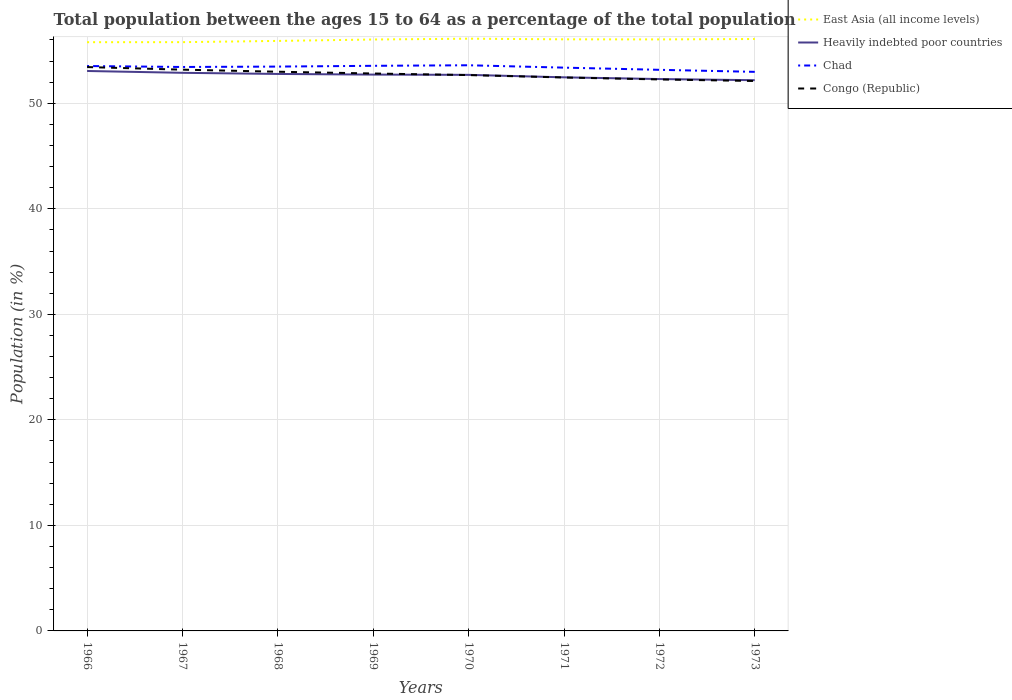Across all years, what is the maximum percentage of the population ages 15 to 64 in Chad?
Your response must be concise. 52.98. In which year was the percentage of the population ages 15 to 64 in East Asia (all income levels) maximum?
Give a very brief answer. 1966. What is the total percentage of the population ages 15 to 64 in Congo (Republic) in the graph?
Make the answer very short. 0.17. What is the difference between the highest and the second highest percentage of the population ages 15 to 64 in East Asia (all income levels)?
Offer a very short reply. 0.33. What is the difference between the highest and the lowest percentage of the population ages 15 to 64 in Chad?
Provide a succinct answer. 5. Is the percentage of the population ages 15 to 64 in Chad strictly greater than the percentage of the population ages 15 to 64 in Congo (Republic) over the years?
Your answer should be compact. No. How many lines are there?
Provide a short and direct response. 4. Does the graph contain any zero values?
Your answer should be very brief. No. Does the graph contain grids?
Provide a short and direct response. Yes. Where does the legend appear in the graph?
Your answer should be very brief. Top right. How many legend labels are there?
Offer a very short reply. 4. What is the title of the graph?
Give a very brief answer. Total population between the ages 15 to 64 as a percentage of the total population. What is the label or title of the Y-axis?
Offer a terse response. Population (in %). What is the Population (in %) of East Asia (all income levels) in 1966?
Offer a very short reply. 55.79. What is the Population (in %) of Heavily indebted poor countries in 1966?
Provide a short and direct response. 53.06. What is the Population (in %) of Chad in 1966?
Your answer should be very brief. 53.53. What is the Population (in %) in Congo (Republic) in 1966?
Make the answer very short. 53.43. What is the Population (in %) in East Asia (all income levels) in 1967?
Offer a very short reply. 55.79. What is the Population (in %) of Heavily indebted poor countries in 1967?
Offer a very short reply. 52.89. What is the Population (in %) in Chad in 1967?
Give a very brief answer. 53.44. What is the Population (in %) in Congo (Republic) in 1967?
Your response must be concise. 53.18. What is the Population (in %) in East Asia (all income levels) in 1968?
Provide a short and direct response. 55.91. What is the Population (in %) of Heavily indebted poor countries in 1968?
Make the answer very short. 52.78. What is the Population (in %) of Chad in 1968?
Offer a terse response. 53.48. What is the Population (in %) of Congo (Republic) in 1968?
Make the answer very short. 52.99. What is the Population (in %) in East Asia (all income levels) in 1969?
Offer a very short reply. 56.04. What is the Population (in %) of Heavily indebted poor countries in 1969?
Ensure brevity in your answer.  52.72. What is the Population (in %) of Chad in 1969?
Make the answer very short. 53.55. What is the Population (in %) in Congo (Republic) in 1969?
Offer a very short reply. 52.82. What is the Population (in %) of East Asia (all income levels) in 1970?
Provide a succinct answer. 56.12. What is the Population (in %) of Heavily indebted poor countries in 1970?
Your response must be concise. 52.69. What is the Population (in %) of Chad in 1970?
Keep it short and to the point. 53.6. What is the Population (in %) of Congo (Republic) in 1970?
Offer a very short reply. 52.67. What is the Population (in %) in East Asia (all income levels) in 1971?
Offer a very short reply. 56.06. What is the Population (in %) in Heavily indebted poor countries in 1971?
Your answer should be compact. 52.46. What is the Population (in %) in Chad in 1971?
Provide a succinct answer. 53.38. What is the Population (in %) of Congo (Republic) in 1971?
Your answer should be very brief. 52.44. What is the Population (in %) in East Asia (all income levels) in 1972?
Keep it short and to the point. 56.05. What is the Population (in %) of Heavily indebted poor countries in 1972?
Keep it short and to the point. 52.29. What is the Population (in %) of Chad in 1972?
Your answer should be very brief. 53.17. What is the Population (in %) of Congo (Republic) in 1972?
Give a very brief answer. 52.26. What is the Population (in %) in East Asia (all income levels) in 1973?
Your answer should be very brief. 56.09. What is the Population (in %) in Heavily indebted poor countries in 1973?
Your answer should be very brief. 52.19. What is the Population (in %) in Chad in 1973?
Provide a short and direct response. 52.98. What is the Population (in %) of Congo (Republic) in 1973?
Ensure brevity in your answer.  52.11. Across all years, what is the maximum Population (in %) of East Asia (all income levels)?
Provide a succinct answer. 56.12. Across all years, what is the maximum Population (in %) in Heavily indebted poor countries?
Your answer should be compact. 53.06. Across all years, what is the maximum Population (in %) of Chad?
Provide a short and direct response. 53.6. Across all years, what is the maximum Population (in %) of Congo (Republic)?
Provide a short and direct response. 53.43. Across all years, what is the minimum Population (in %) of East Asia (all income levels)?
Ensure brevity in your answer.  55.79. Across all years, what is the minimum Population (in %) of Heavily indebted poor countries?
Offer a very short reply. 52.19. Across all years, what is the minimum Population (in %) of Chad?
Your answer should be compact. 52.98. Across all years, what is the minimum Population (in %) in Congo (Republic)?
Offer a very short reply. 52.11. What is the total Population (in %) in East Asia (all income levels) in the graph?
Give a very brief answer. 447.84. What is the total Population (in %) in Heavily indebted poor countries in the graph?
Your answer should be very brief. 421.06. What is the total Population (in %) in Chad in the graph?
Your answer should be very brief. 427.11. What is the total Population (in %) of Congo (Republic) in the graph?
Provide a short and direct response. 421.9. What is the difference between the Population (in %) of East Asia (all income levels) in 1966 and that in 1967?
Give a very brief answer. -0. What is the difference between the Population (in %) of Heavily indebted poor countries in 1966 and that in 1967?
Ensure brevity in your answer.  0.17. What is the difference between the Population (in %) in Chad in 1966 and that in 1967?
Make the answer very short. 0.09. What is the difference between the Population (in %) of Congo (Republic) in 1966 and that in 1967?
Keep it short and to the point. 0.25. What is the difference between the Population (in %) of East Asia (all income levels) in 1966 and that in 1968?
Offer a very short reply. -0.12. What is the difference between the Population (in %) of Heavily indebted poor countries in 1966 and that in 1968?
Offer a terse response. 0.28. What is the difference between the Population (in %) of Chad in 1966 and that in 1968?
Offer a terse response. 0.05. What is the difference between the Population (in %) of Congo (Republic) in 1966 and that in 1968?
Ensure brevity in your answer.  0.44. What is the difference between the Population (in %) in East Asia (all income levels) in 1966 and that in 1969?
Your response must be concise. -0.26. What is the difference between the Population (in %) of Heavily indebted poor countries in 1966 and that in 1969?
Your answer should be compact. 0.34. What is the difference between the Population (in %) in Chad in 1966 and that in 1969?
Your response must be concise. -0.02. What is the difference between the Population (in %) of Congo (Republic) in 1966 and that in 1969?
Provide a succinct answer. 0.61. What is the difference between the Population (in %) in East Asia (all income levels) in 1966 and that in 1970?
Your answer should be compact. -0.33. What is the difference between the Population (in %) in Heavily indebted poor countries in 1966 and that in 1970?
Keep it short and to the point. 0.37. What is the difference between the Population (in %) of Chad in 1966 and that in 1970?
Your response must be concise. -0.07. What is the difference between the Population (in %) in Congo (Republic) in 1966 and that in 1970?
Ensure brevity in your answer.  0.76. What is the difference between the Population (in %) of East Asia (all income levels) in 1966 and that in 1971?
Your answer should be compact. -0.27. What is the difference between the Population (in %) of Heavily indebted poor countries in 1966 and that in 1971?
Ensure brevity in your answer.  0.6. What is the difference between the Population (in %) of Chad in 1966 and that in 1971?
Give a very brief answer. 0.15. What is the difference between the Population (in %) in Congo (Republic) in 1966 and that in 1971?
Your answer should be compact. 0.99. What is the difference between the Population (in %) of East Asia (all income levels) in 1966 and that in 1972?
Ensure brevity in your answer.  -0.26. What is the difference between the Population (in %) of Heavily indebted poor countries in 1966 and that in 1972?
Offer a terse response. 0.76. What is the difference between the Population (in %) in Chad in 1966 and that in 1972?
Offer a very short reply. 0.36. What is the difference between the Population (in %) in Congo (Republic) in 1966 and that in 1972?
Ensure brevity in your answer.  1.17. What is the difference between the Population (in %) in East Asia (all income levels) in 1966 and that in 1973?
Your answer should be compact. -0.3. What is the difference between the Population (in %) of Heavily indebted poor countries in 1966 and that in 1973?
Offer a terse response. 0.87. What is the difference between the Population (in %) of Chad in 1966 and that in 1973?
Give a very brief answer. 0.55. What is the difference between the Population (in %) in Congo (Republic) in 1966 and that in 1973?
Your answer should be very brief. 1.32. What is the difference between the Population (in %) in East Asia (all income levels) in 1967 and that in 1968?
Provide a succinct answer. -0.12. What is the difference between the Population (in %) of Heavily indebted poor countries in 1967 and that in 1968?
Ensure brevity in your answer.  0.11. What is the difference between the Population (in %) in Chad in 1967 and that in 1968?
Make the answer very short. -0.04. What is the difference between the Population (in %) of Congo (Republic) in 1967 and that in 1968?
Make the answer very short. 0.2. What is the difference between the Population (in %) of East Asia (all income levels) in 1967 and that in 1969?
Provide a succinct answer. -0.25. What is the difference between the Population (in %) of Heavily indebted poor countries in 1967 and that in 1969?
Offer a very short reply. 0.17. What is the difference between the Population (in %) in Chad in 1967 and that in 1969?
Your response must be concise. -0.11. What is the difference between the Population (in %) of Congo (Republic) in 1967 and that in 1969?
Your response must be concise. 0.36. What is the difference between the Population (in %) of East Asia (all income levels) in 1967 and that in 1970?
Make the answer very short. -0.33. What is the difference between the Population (in %) in Heavily indebted poor countries in 1967 and that in 1970?
Your response must be concise. 0.19. What is the difference between the Population (in %) of Chad in 1967 and that in 1970?
Ensure brevity in your answer.  -0.16. What is the difference between the Population (in %) in Congo (Republic) in 1967 and that in 1970?
Provide a succinct answer. 0.51. What is the difference between the Population (in %) of East Asia (all income levels) in 1967 and that in 1971?
Your answer should be very brief. -0.27. What is the difference between the Population (in %) in Heavily indebted poor countries in 1967 and that in 1971?
Make the answer very short. 0.43. What is the difference between the Population (in %) of Chad in 1967 and that in 1971?
Your response must be concise. 0.06. What is the difference between the Population (in %) of Congo (Republic) in 1967 and that in 1971?
Offer a terse response. 0.74. What is the difference between the Population (in %) in East Asia (all income levels) in 1967 and that in 1972?
Offer a very short reply. -0.26. What is the difference between the Population (in %) of Heavily indebted poor countries in 1967 and that in 1972?
Your answer should be compact. 0.59. What is the difference between the Population (in %) in Chad in 1967 and that in 1972?
Ensure brevity in your answer.  0.27. What is the difference between the Population (in %) in Congo (Republic) in 1967 and that in 1972?
Offer a very short reply. 0.93. What is the difference between the Population (in %) in East Asia (all income levels) in 1967 and that in 1973?
Your response must be concise. -0.3. What is the difference between the Population (in %) in Heavily indebted poor countries in 1967 and that in 1973?
Offer a very short reply. 0.7. What is the difference between the Population (in %) in Chad in 1967 and that in 1973?
Offer a very short reply. 0.46. What is the difference between the Population (in %) of Congo (Republic) in 1967 and that in 1973?
Offer a terse response. 1.07. What is the difference between the Population (in %) of East Asia (all income levels) in 1968 and that in 1969?
Your answer should be very brief. -0.13. What is the difference between the Population (in %) in Heavily indebted poor countries in 1968 and that in 1969?
Make the answer very short. 0.06. What is the difference between the Population (in %) in Chad in 1968 and that in 1969?
Keep it short and to the point. -0.07. What is the difference between the Population (in %) in Congo (Republic) in 1968 and that in 1969?
Your answer should be compact. 0.17. What is the difference between the Population (in %) of East Asia (all income levels) in 1968 and that in 1970?
Make the answer very short. -0.21. What is the difference between the Population (in %) of Heavily indebted poor countries in 1968 and that in 1970?
Provide a short and direct response. 0.09. What is the difference between the Population (in %) in Chad in 1968 and that in 1970?
Your answer should be very brief. -0.12. What is the difference between the Population (in %) of Congo (Republic) in 1968 and that in 1970?
Provide a succinct answer. 0.32. What is the difference between the Population (in %) of East Asia (all income levels) in 1968 and that in 1971?
Make the answer very short. -0.15. What is the difference between the Population (in %) of Heavily indebted poor countries in 1968 and that in 1971?
Your response must be concise. 0.32. What is the difference between the Population (in %) of Chad in 1968 and that in 1971?
Your answer should be very brief. 0.1. What is the difference between the Population (in %) in Congo (Republic) in 1968 and that in 1971?
Keep it short and to the point. 0.54. What is the difference between the Population (in %) in East Asia (all income levels) in 1968 and that in 1972?
Offer a very short reply. -0.14. What is the difference between the Population (in %) of Heavily indebted poor countries in 1968 and that in 1972?
Ensure brevity in your answer.  0.48. What is the difference between the Population (in %) in Chad in 1968 and that in 1972?
Offer a terse response. 0.31. What is the difference between the Population (in %) of Congo (Republic) in 1968 and that in 1972?
Ensure brevity in your answer.  0.73. What is the difference between the Population (in %) of East Asia (all income levels) in 1968 and that in 1973?
Offer a very short reply. -0.18. What is the difference between the Population (in %) of Heavily indebted poor countries in 1968 and that in 1973?
Give a very brief answer. 0.59. What is the difference between the Population (in %) of Chad in 1968 and that in 1973?
Make the answer very short. 0.5. What is the difference between the Population (in %) in Congo (Republic) in 1968 and that in 1973?
Offer a terse response. 0.88. What is the difference between the Population (in %) in East Asia (all income levels) in 1969 and that in 1970?
Keep it short and to the point. -0.08. What is the difference between the Population (in %) in Heavily indebted poor countries in 1969 and that in 1970?
Keep it short and to the point. 0.03. What is the difference between the Population (in %) in Chad in 1969 and that in 1970?
Offer a very short reply. -0.05. What is the difference between the Population (in %) in Congo (Republic) in 1969 and that in 1970?
Your answer should be compact. 0.15. What is the difference between the Population (in %) of East Asia (all income levels) in 1969 and that in 1971?
Keep it short and to the point. -0.02. What is the difference between the Population (in %) of Heavily indebted poor countries in 1969 and that in 1971?
Your answer should be very brief. 0.26. What is the difference between the Population (in %) of Chad in 1969 and that in 1971?
Your response must be concise. 0.17. What is the difference between the Population (in %) in Congo (Republic) in 1969 and that in 1971?
Ensure brevity in your answer.  0.38. What is the difference between the Population (in %) in East Asia (all income levels) in 1969 and that in 1972?
Provide a short and direct response. -0.01. What is the difference between the Population (in %) in Heavily indebted poor countries in 1969 and that in 1972?
Your answer should be very brief. 0.42. What is the difference between the Population (in %) of Chad in 1969 and that in 1972?
Provide a short and direct response. 0.38. What is the difference between the Population (in %) of Congo (Republic) in 1969 and that in 1972?
Ensure brevity in your answer.  0.56. What is the difference between the Population (in %) in East Asia (all income levels) in 1969 and that in 1973?
Your response must be concise. -0.05. What is the difference between the Population (in %) in Heavily indebted poor countries in 1969 and that in 1973?
Make the answer very short. 0.53. What is the difference between the Population (in %) in Chad in 1969 and that in 1973?
Provide a succinct answer. 0.57. What is the difference between the Population (in %) in Congo (Republic) in 1969 and that in 1973?
Your response must be concise. 0.71. What is the difference between the Population (in %) in East Asia (all income levels) in 1970 and that in 1971?
Give a very brief answer. 0.06. What is the difference between the Population (in %) in Heavily indebted poor countries in 1970 and that in 1971?
Offer a terse response. 0.23. What is the difference between the Population (in %) in Chad in 1970 and that in 1971?
Give a very brief answer. 0.22. What is the difference between the Population (in %) in Congo (Republic) in 1970 and that in 1971?
Your answer should be very brief. 0.23. What is the difference between the Population (in %) in East Asia (all income levels) in 1970 and that in 1972?
Your response must be concise. 0.07. What is the difference between the Population (in %) in Heavily indebted poor countries in 1970 and that in 1972?
Keep it short and to the point. 0.4. What is the difference between the Population (in %) of Chad in 1970 and that in 1972?
Keep it short and to the point. 0.43. What is the difference between the Population (in %) of Congo (Republic) in 1970 and that in 1972?
Offer a very short reply. 0.41. What is the difference between the Population (in %) of East Asia (all income levels) in 1970 and that in 1973?
Provide a succinct answer. 0.03. What is the difference between the Population (in %) in Heavily indebted poor countries in 1970 and that in 1973?
Your answer should be compact. 0.5. What is the difference between the Population (in %) in Chad in 1970 and that in 1973?
Offer a terse response. 0.62. What is the difference between the Population (in %) in Congo (Republic) in 1970 and that in 1973?
Make the answer very short. 0.56. What is the difference between the Population (in %) in East Asia (all income levels) in 1971 and that in 1972?
Give a very brief answer. 0.01. What is the difference between the Population (in %) of Heavily indebted poor countries in 1971 and that in 1972?
Keep it short and to the point. 0.16. What is the difference between the Population (in %) of Chad in 1971 and that in 1972?
Provide a succinct answer. 0.21. What is the difference between the Population (in %) of Congo (Republic) in 1971 and that in 1972?
Provide a succinct answer. 0.19. What is the difference between the Population (in %) in East Asia (all income levels) in 1971 and that in 1973?
Keep it short and to the point. -0.03. What is the difference between the Population (in %) in Heavily indebted poor countries in 1971 and that in 1973?
Provide a short and direct response. 0.27. What is the difference between the Population (in %) in Chad in 1971 and that in 1973?
Offer a very short reply. 0.4. What is the difference between the Population (in %) of Congo (Republic) in 1971 and that in 1973?
Your response must be concise. 0.33. What is the difference between the Population (in %) in East Asia (all income levels) in 1972 and that in 1973?
Provide a succinct answer. -0.04. What is the difference between the Population (in %) of Heavily indebted poor countries in 1972 and that in 1973?
Ensure brevity in your answer.  0.11. What is the difference between the Population (in %) of Chad in 1972 and that in 1973?
Offer a terse response. 0.19. What is the difference between the Population (in %) of Congo (Republic) in 1972 and that in 1973?
Make the answer very short. 0.15. What is the difference between the Population (in %) of East Asia (all income levels) in 1966 and the Population (in %) of Heavily indebted poor countries in 1967?
Offer a terse response. 2.9. What is the difference between the Population (in %) in East Asia (all income levels) in 1966 and the Population (in %) in Chad in 1967?
Your response must be concise. 2.35. What is the difference between the Population (in %) in East Asia (all income levels) in 1966 and the Population (in %) in Congo (Republic) in 1967?
Offer a terse response. 2.6. What is the difference between the Population (in %) in Heavily indebted poor countries in 1966 and the Population (in %) in Chad in 1967?
Provide a short and direct response. -0.38. What is the difference between the Population (in %) of Heavily indebted poor countries in 1966 and the Population (in %) of Congo (Republic) in 1967?
Offer a terse response. -0.13. What is the difference between the Population (in %) in Chad in 1966 and the Population (in %) in Congo (Republic) in 1967?
Provide a short and direct response. 0.34. What is the difference between the Population (in %) of East Asia (all income levels) in 1966 and the Population (in %) of Heavily indebted poor countries in 1968?
Give a very brief answer. 3.01. What is the difference between the Population (in %) of East Asia (all income levels) in 1966 and the Population (in %) of Chad in 1968?
Give a very brief answer. 2.31. What is the difference between the Population (in %) in East Asia (all income levels) in 1966 and the Population (in %) in Congo (Republic) in 1968?
Your answer should be compact. 2.8. What is the difference between the Population (in %) of Heavily indebted poor countries in 1966 and the Population (in %) of Chad in 1968?
Make the answer very short. -0.42. What is the difference between the Population (in %) of Heavily indebted poor countries in 1966 and the Population (in %) of Congo (Republic) in 1968?
Provide a short and direct response. 0.07. What is the difference between the Population (in %) in Chad in 1966 and the Population (in %) in Congo (Republic) in 1968?
Offer a terse response. 0.54. What is the difference between the Population (in %) of East Asia (all income levels) in 1966 and the Population (in %) of Heavily indebted poor countries in 1969?
Provide a short and direct response. 3.07. What is the difference between the Population (in %) in East Asia (all income levels) in 1966 and the Population (in %) in Chad in 1969?
Your response must be concise. 2.24. What is the difference between the Population (in %) of East Asia (all income levels) in 1966 and the Population (in %) of Congo (Republic) in 1969?
Your answer should be very brief. 2.97. What is the difference between the Population (in %) in Heavily indebted poor countries in 1966 and the Population (in %) in Chad in 1969?
Your answer should be very brief. -0.49. What is the difference between the Population (in %) of Heavily indebted poor countries in 1966 and the Population (in %) of Congo (Republic) in 1969?
Make the answer very short. 0.24. What is the difference between the Population (in %) of Chad in 1966 and the Population (in %) of Congo (Republic) in 1969?
Provide a short and direct response. 0.71. What is the difference between the Population (in %) in East Asia (all income levels) in 1966 and the Population (in %) in Heavily indebted poor countries in 1970?
Your response must be concise. 3.1. What is the difference between the Population (in %) in East Asia (all income levels) in 1966 and the Population (in %) in Chad in 1970?
Make the answer very short. 2.19. What is the difference between the Population (in %) in East Asia (all income levels) in 1966 and the Population (in %) in Congo (Republic) in 1970?
Provide a succinct answer. 3.12. What is the difference between the Population (in %) of Heavily indebted poor countries in 1966 and the Population (in %) of Chad in 1970?
Your answer should be very brief. -0.54. What is the difference between the Population (in %) in Heavily indebted poor countries in 1966 and the Population (in %) in Congo (Republic) in 1970?
Give a very brief answer. 0.39. What is the difference between the Population (in %) of Chad in 1966 and the Population (in %) of Congo (Republic) in 1970?
Provide a short and direct response. 0.86. What is the difference between the Population (in %) of East Asia (all income levels) in 1966 and the Population (in %) of Heavily indebted poor countries in 1971?
Your answer should be compact. 3.33. What is the difference between the Population (in %) in East Asia (all income levels) in 1966 and the Population (in %) in Chad in 1971?
Make the answer very short. 2.41. What is the difference between the Population (in %) of East Asia (all income levels) in 1966 and the Population (in %) of Congo (Republic) in 1971?
Give a very brief answer. 3.34. What is the difference between the Population (in %) of Heavily indebted poor countries in 1966 and the Population (in %) of Chad in 1971?
Ensure brevity in your answer.  -0.32. What is the difference between the Population (in %) of Heavily indebted poor countries in 1966 and the Population (in %) of Congo (Republic) in 1971?
Offer a very short reply. 0.61. What is the difference between the Population (in %) of Chad in 1966 and the Population (in %) of Congo (Republic) in 1971?
Give a very brief answer. 1.09. What is the difference between the Population (in %) of East Asia (all income levels) in 1966 and the Population (in %) of Heavily indebted poor countries in 1972?
Provide a succinct answer. 3.49. What is the difference between the Population (in %) in East Asia (all income levels) in 1966 and the Population (in %) in Chad in 1972?
Make the answer very short. 2.62. What is the difference between the Population (in %) in East Asia (all income levels) in 1966 and the Population (in %) in Congo (Republic) in 1972?
Keep it short and to the point. 3.53. What is the difference between the Population (in %) in Heavily indebted poor countries in 1966 and the Population (in %) in Chad in 1972?
Your answer should be compact. -0.11. What is the difference between the Population (in %) of Heavily indebted poor countries in 1966 and the Population (in %) of Congo (Republic) in 1972?
Your answer should be very brief. 0.8. What is the difference between the Population (in %) of Chad in 1966 and the Population (in %) of Congo (Republic) in 1972?
Your answer should be very brief. 1.27. What is the difference between the Population (in %) in East Asia (all income levels) in 1966 and the Population (in %) in Heavily indebted poor countries in 1973?
Your response must be concise. 3.6. What is the difference between the Population (in %) in East Asia (all income levels) in 1966 and the Population (in %) in Chad in 1973?
Keep it short and to the point. 2.81. What is the difference between the Population (in %) of East Asia (all income levels) in 1966 and the Population (in %) of Congo (Republic) in 1973?
Make the answer very short. 3.68. What is the difference between the Population (in %) in Heavily indebted poor countries in 1966 and the Population (in %) in Chad in 1973?
Give a very brief answer. 0.08. What is the difference between the Population (in %) of Heavily indebted poor countries in 1966 and the Population (in %) of Congo (Republic) in 1973?
Ensure brevity in your answer.  0.95. What is the difference between the Population (in %) of Chad in 1966 and the Population (in %) of Congo (Republic) in 1973?
Offer a terse response. 1.42. What is the difference between the Population (in %) in East Asia (all income levels) in 1967 and the Population (in %) in Heavily indebted poor countries in 1968?
Your answer should be compact. 3.01. What is the difference between the Population (in %) of East Asia (all income levels) in 1967 and the Population (in %) of Chad in 1968?
Make the answer very short. 2.31. What is the difference between the Population (in %) of East Asia (all income levels) in 1967 and the Population (in %) of Congo (Republic) in 1968?
Offer a very short reply. 2.8. What is the difference between the Population (in %) of Heavily indebted poor countries in 1967 and the Population (in %) of Chad in 1968?
Provide a short and direct response. -0.59. What is the difference between the Population (in %) in Heavily indebted poor countries in 1967 and the Population (in %) in Congo (Republic) in 1968?
Give a very brief answer. -0.1. What is the difference between the Population (in %) of Chad in 1967 and the Population (in %) of Congo (Republic) in 1968?
Give a very brief answer. 0.45. What is the difference between the Population (in %) of East Asia (all income levels) in 1967 and the Population (in %) of Heavily indebted poor countries in 1969?
Provide a short and direct response. 3.07. What is the difference between the Population (in %) in East Asia (all income levels) in 1967 and the Population (in %) in Chad in 1969?
Make the answer very short. 2.24. What is the difference between the Population (in %) in East Asia (all income levels) in 1967 and the Population (in %) in Congo (Republic) in 1969?
Provide a short and direct response. 2.97. What is the difference between the Population (in %) in Heavily indebted poor countries in 1967 and the Population (in %) in Chad in 1969?
Keep it short and to the point. -0.66. What is the difference between the Population (in %) in Heavily indebted poor countries in 1967 and the Population (in %) in Congo (Republic) in 1969?
Keep it short and to the point. 0.07. What is the difference between the Population (in %) in Chad in 1967 and the Population (in %) in Congo (Republic) in 1969?
Ensure brevity in your answer.  0.62. What is the difference between the Population (in %) of East Asia (all income levels) in 1967 and the Population (in %) of Heavily indebted poor countries in 1970?
Keep it short and to the point. 3.1. What is the difference between the Population (in %) of East Asia (all income levels) in 1967 and the Population (in %) of Chad in 1970?
Keep it short and to the point. 2.19. What is the difference between the Population (in %) of East Asia (all income levels) in 1967 and the Population (in %) of Congo (Republic) in 1970?
Your response must be concise. 3.12. What is the difference between the Population (in %) in Heavily indebted poor countries in 1967 and the Population (in %) in Chad in 1970?
Your response must be concise. -0.71. What is the difference between the Population (in %) in Heavily indebted poor countries in 1967 and the Population (in %) in Congo (Republic) in 1970?
Provide a succinct answer. 0.21. What is the difference between the Population (in %) of Chad in 1967 and the Population (in %) of Congo (Republic) in 1970?
Your response must be concise. 0.77. What is the difference between the Population (in %) in East Asia (all income levels) in 1967 and the Population (in %) in Heavily indebted poor countries in 1971?
Make the answer very short. 3.33. What is the difference between the Population (in %) of East Asia (all income levels) in 1967 and the Population (in %) of Chad in 1971?
Make the answer very short. 2.41. What is the difference between the Population (in %) of East Asia (all income levels) in 1967 and the Population (in %) of Congo (Republic) in 1971?
Your answer should be compact. 3.35. What is the difference between the Population (in %) of Heavily indebted poor countries in 1967 and the Population (in %) of Chad in 1971?
Give a very brief answer. -0.49. What is the difference between the Population (in %) of Heavily indebted poor countries in 1967 and the Population (in %) of Congo (Republic) in 1971?
Give a very brief answer. 0.44. What is the difference between the Population (in %) of Chad in 1967 and the Population (in %) of Congo (Republic) in 1971?
Your answer should be compact. 0.99. What is the difference between the Population (in %) of East Asia (all income levels) in 1967 and the Population (in %) of Heavily indebted poor countries in 1972?
Offer a very short reply. 3.5. What is the difference between the Population (in %) of East Asia (all income levels) in 1967 and the Population (in %) of Chad in 1972?
Make the answer very short. 2.62. What is the difference between the Population (in %) in East Asia (all income levels) in 1967 and the Population (in %) in Congo (Republic) in 1972?
Make the answer very short. 3.53. What is the difference between the Population (in %) of Heavily indebted poor countries in 1967 and the Population (in %) of Chad in 1972?
Provide a succinct answer. -0.28. What is the difference between the Population (in %) of Heavily indebted poor countries in 1967 and the Population (in %) of Congo (Republic) in 1972?
Your response must be concise. 0.63. What is the difference between the Population (in %) of Chad in 1967 and the Population (in %) of Congo (Republic) in 1972?
Provide a succinct answer. 1.18. What is the difference between the Population (in %) of East Asia (all income levels) in 1967 and the Population (in %) of Heavily indebted poor countries in 1973?
Keep it short and to the point. 3.6. What is the difference between the Population (in %) of East Asia (all income levels) in 1967 and the Population (in %) of Chad in 1973?
Offer a terse response. 2.81. What is the difference between the Population (in %) in East Asia (all income levels) in 1967 and the Population (in %) in Congo (Republic) in 1973?
Provide a succinct answer. 3.68. What is the difference between the Population (in %) in Heavily indebted poor countries in 1967 and the Population (in %) in Chad in 1973?
Provide a short and direct response. -0.09. What is the difference between the Population (in %) of Heavily indebted poor countries in 1967 and the Population (in %) of Congo (Republic) in 1973?
Make the answer very short. 0.78. What is the difference between the Population (in %) in Chad in 1967 and the Population (in %) in Congo (Republic) in 1973?
Give a very brief answer. 1.33. What is the difference between the Population (in %) in East Asia (all income levels) in 1968 and the Population (in %) in Heavily indebted poor countries in 1969?
Provide a succinct answer. 3.19. What is the difference between the Population (in %) in East Asia (all income levels) in 1968 and the Population (in %) in Chad in 1969?
Your answer should be compact. 2.36. What is the difference between the Population (in %) in East Asia (all income levels) in 1968 and the Population (in %) in Congo (Republic) in 1969?
Your answer should be compact. 3.09. What is the difference between the Population (in %) in Heavily indebted poor countries in 1968 and the Population (in %) in Chad in 1969?
Ensure brevity in your answer.  -0.77. What is the difference between the Population (in %) of Heavily indebted poor countries in 1968 and the Population (in %) of Congo (Republic) in 1969?
Your response must be concise. -0.04. What is the difference between the Population (in %) in Chad in 1968 and the Population (in %) in Congo (Republic) in 1969?
Offer a very short reply. 0.66. What is the difference between the Population (in %) in East Asia (all income levels) in 1968 and the Population (in %) in Heavily indebted poor countries in 1970?
Ensure brevity in your answer.  3.22. What is the difference between the Population (in %) in East Asia (all income levels) in 1968 and the Population (in %) in Chad in 1970?
Offer a very short reply. 2.31. What is the difference between the Population (in %) in East Asia (all income levels) in 1968 and the Population (in %) in Congo (Republic) in 1970?
Your answer should be compact. 3.24. What is the difference between the Population (in %) in Heavily indebted poor countries in 1968 and the Population (in %) in Chad in 1970?
Your answer should be very brief. -0.82. What is the difference between the Population (in %) in Heavily indebted poor countries in 1968 and the Population (in %) in Congo (Republic) in 1970?
Make the answer very short. 0.11. What is the difference between the Population (in %) in Chad in 1968 and the Population (in %) in Congo (Republic) in 1970?
Ensure brevity in your answer.  0.8. What is the difference between the Population (in %) of East Asia (all income levels) in 1968 and the Population (in %) of Heavily indebted poor countries in 1971?
Offer a very short reply. 3.45. What is the difference between the Population (in %) in East Asia (all income levels) in 1968 and the Population (in %) in Chad in 1971?
Provide a succinct answer. 2.53. What is the difference between the Population (in %) in East Asia (all income levels) in 1968 and the Population (in %) in Congo (Republic) in 1971?
Make the answer very short. 3.46. What is the difference between the Population (in %) in Heavily indebted poor countries in 1968 and the Population (in %) in Chad in 1971?
Provide a succinct answer. -0.6. What is the difference between the Population (in %) in Heavily indebted poor countries in 1968 and the Population (in %) in Congo (Republic) in 1971?
Keep it short and to the point. 0.33. What is the difference between the Population (in %) of Chad in 1968 and the Population (in %) of Congo (Republic) in 1971?
Give a very brief answer. 1.03. What is the difference between the Population (in %) of East Asia (all income levels) in 1968 and the Population (in %) of Heavily indebted poor countries in 1972?
Your answer should be very brief. 3.61. What is the difference between the Population (in %) in East Asia (all income levels) in 1968 and the Population (in %) in Chad in 1972?
Provide a succinct answer. 2.74. What is the difference between the Population (in %) in East Asia (all income levels) in 1968 and the Population (in %) in Congo (Republic) in 1972?
Ensure brevity in your answer.  3.65. What is the difference between the Population (in %) in Heavily indebted poor countries in 1968 and the Population (in %) in Chad in 1972?
Offer a very short reply. -0.39. What is the difference between the Population (in %) in Heavily indebted poor countries in 1968 and the Population (in %) in Congo (Republic) in 1972?
Give a very brief answer. 0.52. What is the difference between the Population (in %) in Chad in 1968 and the Population (in %) in Congo (Republic) in 1972?
Offer a terse response. 1.22. What is the difference between the Population (in %) of East Asia (all income levels) in 1968 and the Population (in %) of Heavily indebted poor countries in 1973?
Give a very brief answer. 3.72. What is the difference between the Population (in %) in East Asia (all income levels) in 1968 and the Population (in %) in Chad in 1973?
Your answer should be compact. 2.93. What is the difference between the Population (in %) of East Asia (all income levels) in 1968 and the Population (in %) of Congo (Republic) in 1973?
Your answer should be very brief. 3.8. What is the difference between the Population (in %) of Heavily indebted poor countries in 1968 and the Population (in %) of Chad in 1973?
Keep it short and to the point. -0.2. What is the difference between the Population (in %) of Heavily indebted poor countries in 1968 and the Population (in %) of Congo (Republic) in 1973?
Offer a terse response. 0.67. What is the difference between the Population (in %) of Chad in 1968 and the Population (in %) of Congo (Republic) in 1973?
Ensure brevity in your answer.  1.37. What is the difference between the Population (in %) of East Asia (all income levels) in 1969 and the Population (in %) of Heavily indebted poor countries in 1970?
Provide a short and direct response. 3.35. What is the difference between the Population (in %) of East Asia (all income levels) in 1969 and the Population (in %) of Chad in 1970?
Ensure brevity in your answer.  2.44. What is the difference between the Population (in %) in East Asia (all income levels) in 1969 and the Population (in %) in Congo (Republic) in 1970?
Provide a short and direct response. 3.37. What is the difference between the Population (in %) of Heavily indebted poor countries in 1969 and the Population (in %) of Chad in 1970?
Keep it short and to the point. -0.88. What is the difference between the Population (in %) in Heavily indebted poor countries in 1969 and the Population (in %) in Congo (Republic) in 1970?
Keep it short and to the point. 0.05. What is the difference between the Population (in %) of Chad in 1969 and the Population (in %) of Congo (Republic) in 1970?
Offer a very short reply. 0.88. What is the difference between the Population (in %) of East Asia (all income levels) in 1969 and the Population (in %) of Heavily indebted poor countries in 1971?
Offer a terse response. 3.58. What is the difference between the Population (in %) of East Asia (all income levels) in 1969 and the Population (in %) of Chad in 1971?
Your answer should be very brief. 2.67. What is the difference between the Population (in %) of East Asia (all income levels) in 1969 and the Population (in %) of Congo (Republic) in 1971?
Offer a very short reply. 3.6. What is the difference between the Population (in %) of Heavily indebted poor countries in 1969 and the Population (in %) of Chad in 1971?
Make the answer very short. -0.66. What is the difference between the Population (in %) of Heavily indebted poor countries in 1969 and the Population (in %) of Congo (Republic) in 1971?
Provide a short and direct response. 0.27. What is the difference between the Population (in %) in Chad in 1969 and the Population (in %) in Congo (Republic) in 1971?
Give a very brief answer. 1.11. What is the difference between the Population (in %) in East Asia (all income levels) in 1969 and the Population (in %) in Heavily indebted poor countries in 1972?
Provide a succinct answer. 3.75. What is the difference between the Population (in %) in East Asia (all income levels) in 1969 and the Population (in %) in Chad in 1972?
Keep it short and to the point. 2.87. What is the difference between the Population (in %) of East Asia (all income levels) in 1969 and the Population (in %) of Congo (Republic) in 1972?
Your answer should be compact. 3.78. What is the difference between the Population (in %) of Heavily indebted poor countries in 1969 and the Population (in %) of Chad in 1972?
Make the answer very short. -0.45. What is the difference between the Population (in %) in Heavily indebted poor countries in 1969 and the Population (in %) in Congo (Republic) in 1972?
Provide a short and direct response. 0.46. What is the difference between the Population (in %) of Chad in 1969 and the Population (in %) of Congo (Republic) in 1972?
Your answer should be compact. 1.29. What is the difference between the Population (in %) of East Asia (all income levels) in 1969 and the Population (in %) of Heavily indebted poor countries in 1973?
Give a very brief answer. 3.85. What is the difference between the Population (in %) of East Asia (all income levels) in 1969 and the Population (in %) of Chad in 1973?
Give a very brief answer. 3.07. What is the difference between the Population (in %) in East Asia (all income levels) in 1969 and the Population (in %) in Congo (Republic) in 1973?
Make the answer very short. 3.93. What is the difference between the Population (in %) of Heavily indebted poor countries in 1969 and the Population (in %) of Chad in 1973?
Your answer should be very brief. -0.26. What is the difference between the Population (in %) of Heavily indebted poor countries in 1969 and the Population (in %) of Congo (Republic) in 1973?
Offer a very short reply. 0.61. What is the difference between the Population (in %) in Chad in 1969 and the Population (in %) in Congo (Republic) in 1973?
Offer a terse response. 1.44. What is the difference between the Population (in %) of East Asia (all income levels) in 1970 and the Population (in %) of Heavily indebted poor countries in 1971?
Keep it short and to the point. 3.66. What is the difference between the Population (in %) of East Asia (all income levels) in 1970 and the Population (in %) of Chad in 1971?
Provide a succinct answer. 2.74. What is the difference between the Population (in %) of East Asia (all income levels) in 1970 and the Population (in %) of Congo (Republic) in 1971?
Ensure brevity in your answer.  3.68. What is the difference between the Population (in %) in Heavily indebted poor countries in 1970 and the Population (in %) in Chad in 1971?
Ensure brevity in your answer.  -0.68. What is the difference between the Population (in %) in Heavily indebted poor countries in 1970 and the Population (in %) in Congo (Republic) in 1971?
Keep it short and to the point. 0.25. What is the difference between the Population (in %) of Chad in 1970 and the Population (in %) of Congo (Republic) in 1971?
Offer a terse response. 1.16. What is the difference between the Population (in %) in East Asia (all income levels) in 1970 and the Population (in %) in Heavily indebted poor countries in 1972?
Your answer should be very brief. 3.82. What is the difference between the Population (in %) in East Asia (all income levels) in 1970 and the Population (in %) in Chad in 1972?
Ensure brevity in your answer.  2.95. What is the difference between the Population (in %) of East Asia (all income levels) in 1970 and the Population (in %) of Congo (Republic) in 1972?
Offer a very short reply. 3.86. What is the difference between the Population (in %) in Heavily indebted poor countries in 1970 and the Population (in %) in Chad in 1972?
Your answer should be very brief. -0.48. What is the difference between the Population (in %) of Heavily indebted poor countries in 1970 and the Population (in %) of Congo (Republic) in 1972?
Your answer should be very brief. 0.43. What is the difference between the Population (in %) of Chad in 1970 and the Population (in %) of Congo (Republic) in 1972?
Provide a succinct answer. 1.34. What is the difference between the Population (in %) of East Asia (all income levels) in 1970 and the Population (in %) of Heavily indebted poor countries in 1973?
Your answer should be very brief. 3.93. What is the difference between the Population (in %) in East Asia (all income levels) in 1970 and the Population (in %) in Chad in 1973?
Provide a short and direct response. 3.14. What is the difference between the Population (in %) in East Asia (all income levels) in 1970 and the Population (in %) in Congo (Republic) in 1973?
Your answer should be compact. 4.01. What is the difference between the Population (in %) of Heavily indebted poor countries in 1970 and the Population (in %) of Chad in 1973?
Ensure brevity in your answer.  -0.29. What is the difference between the Population (in %) of Heavily indebted poor countries in 1970 and the Population (in %) of Congo (Republic) in 1973?
Offer a very short reply. 0.58. What is the difference between the Population (in %) in Chad in 1970 and the Population (in %) in Congo (Republic) in 1973?
Provide a short and direct response. 1.49. What is the difference between the Population (in %) in East Asia (all income levels) in 1971 and the Population (in %) in Heavily indebted poor countries in 1972?
Offer a very short reply. 3.77. What is the difference between the Population (in %) of East Asia (all income levels) in 1971 and the Population (in %) of Chad in 1972?
Offer a terse response. 2.89. What is the difference between the Population (in %) of East Asia (all income levels) in 1971 and the Population (in %) of Congo (Republic) in 1972?
Offer a terse response. 3.8. What is the difference between the Population (in %) of Heavily indebted poor countries in 1971 and the Population (in %) of Chad in 1972?
Offer a very short reply. -0.71. What is the difference between the Population (in %) of Heavily indebted poor countries in 1971 and the Population (in %) of Congo (Republic) in 1972?
Your answer should be compact. 0.2. What is the difference between the Population (in %) of Chad in 1971 and the Population (in %) of Congo (Republic) in 1972?
Make the answer very short. 1.12. What is the difference between the Population (in %) in East Asia (all income levels) in 1971 and the Population (in %) in Heavily indebted poor countries in 1973?
Make the answer very short. 3.87. What is the difference between the Population (in %) in East Asia (all income levels) in 1971 and the Population (in %) in Chad in 1973?
Provide a short and direct response. 3.08. What is the difference between the Population (in %) in East Asia (all income levels) in 1971 and the Population (in %) in Congo (Republic) in 1973?
Offer a terse response. 3.95. What is the difference between the Population (in %) in Heavily indebted poor countries in 1971 and the Population (in %) in Chad in 1973?
Offer a very short reply. -0.52. What is the difference between the Population (in %) in Heavily indebted poor countries in 1971 and the Population (in %) in Congo (Republic) in 1973?
Your answer should be very brief. 0.35. What is the difference between the Population (in %) of Chad in 1971 and the Population (in %) of Congo (Republic) in 1973?
Your response must be concise. 1.27. What is the difference between the Population (in %) of East Asia (all income levels) in 1972 and the Population (in %) of Heavily indebted poor countries in 1973?
Ensure brevity in your answer.  3.86. What is the difference between the Population (in %) of East Asia (all income levels) in 1972 and the Population (in %) of Chad in 1973?
Your response must be concise. 3.07. What is the difference between the Population (in %) in East Asia (all income levels) in 1972 and the Population (in %) in Congo (Republic) in 1973?
Offer a very short reply. 3.94. What is the difference between the Population (in %) in Heavily indebted poor countries in 1972 and the Population (in %) in Chad in 1973?
Make the answer very short. -0.68. What is the difference between the Population (in %) of Heavily indebted poor countries in 1972 and the Population (in %) of Congo (Republic) in 1973?
Your answer should be very brief. 0.18. What is the difference between the Population (in %) in Chad in 1972 and the Population (in %) in Congo (Republic) in 1973?
Your answer should be compact. 1.06. What is the average Population (in %) of East Asia (all income levels) per year?
Your response must be concise. 55.98. What is the average Population (in %) of Heavily indebted poor countries per year?
Provide a short and direct response. 52.63. What is the average Population (in %) in Chad per year?
Give a very brief answer. 53.39. What is the average Population (in %) in Congo (Republic) per year?
Keep it short and to the point. 52.74. In the year 1966, what is the difference between the Population (in %) of East Asia (all income levels) and Population (in %) of Heavily indebted poor countries?
Provide a short and direct response. 2.73. In the year 1966, what is the difference between the Population (in %) in East Asia (all income levels) and Population (in %) in Chad?
Ensure brevity in your answer.  2.26. In the year 1966, what is the difference between the Population (in %) in East Asia (all income levels) and Population (in %) in Congo (Republic)?
Your answer should be very brief. 2.36. In the year 1966, what is the difference between the Population (in %) of Heavily indebted poor countries and Population (in %) of Chad?
Offer a very short reply. -0.47. In the year 1966, what is the difference between the Population (in %) of Heavily indebted poor countries and Population (in %) of Congo (Republic)?
Provide a succinct answer. -0.37. In the year 1966, what is the difference between the Population (in %) in Chad and Population (in %) in Congo (Republic)?
Keep it short and to the point. 0.1. In the year 1967, what is the difference between the Population (in %) of East Asia (all income levels) and Population (in %) of Heavily indebted poor countries?
Provide a short and direct response. 2.9. In the year 1967, what is the difference between the Population (in %) of East Asia (all income levels) and Population (in %) of Chad?
Offer a terse response. 2.35. In the year 1967, what is the difference between the Population (in %) in East Asia (all income levels) and Population (in %) in Congo (Republic)?
Ensure brevity in your answer.  2.61. In the year 1967, what is the difference between the Population (in %) of Heavily indebted poor countries and Population (in %) of Chad?
Give a very brief answer. -0.55. In the year 1967, what is the difference between the Population (in %) of Heavily indebted poor countries and Population (in %) of Congo (Republic)?
Keep it short and to the point. -0.3. In the year 1967, what is the difference between the Population (in %) in Chad and Population (in %) in Congo (Republic)?
Give a very brief answer. 0.25. In the year 1968, what is the difference between the Population (in %) in East Asia (all income levels) and Population (in %) in Heavily indebted poor countries?
Provide a short and direct response. 3.13. In the year 1968, what is the difference between the Population (in %) of East Asia (all income levels) and Population (in %) of Chad?
Provide a short and direct response. 2.43. In the year 1968, what is the difference between the Population (in %) in East Asia (all income levels) and Population (in %) in Congo (Republic)?
Your answer should be compact. 2.92. In the year 1968, what is the difference between the Population (in %) in Heavily indebted poor countries and Population (in %) in Chad?
Your response must be concise. -0.7. In the year 1968, what is the difference between the Population (in %) of Heavily indebted poor countries and Population (in %) of Congo (Republic)?
Provide a succinct answer. -0.21. In the year 1968, what is the difference between the Population (in %) in Chad and Population (in %) in Congo (Republic)?
Provide a short and direct response. 0.49. In the year 1969, what is the difference between the Population (in %) of East Asia (all income levels) and Population (in %) of Heavily indebted poor countries?
Your answer should be compact. 3.33. In the year 1969, what is the difference between the Population (in %) of East Asia (all income levels) and Population (in %) of Chad?
Your answer should be very brief. 2.49. In the year 1969, what is the difference between the Population (in %) in East Asia (all income levels) and Population (in %) in Congo (Republic)?
Your answer should be very brief. 3.22. In the year 1969, what is the difference between the Population (in %) in Heavily indebted poor countries and Population (in %) in Chad?
Your answer should be compact. -0.83. In the year 1969, what is the difference between the Population (in %) in Heavily indebted poor countries and Population (in %) in Congo (Republic)?
Your response must be concise. -0.1. In the year 1969, what is the difference between the Population (in %) in Chad and Population (in %) in Congo (Republic)?
Your answer should be compact. 0.73. In the year 1970, what is the difference between the Population (in %) of East Asia (all income levels) and Population (in %) of Heavily indebted poor countries?
Give a very brief answer. 3.43. In the year 1970, what is the difference between the Population (in %) in East Asia (all income levels) and Population (in %) in Chad?
Give a very brief answer. 2.52. In the year 1970, what is the difference between the Population (in %) in East Asia (all income levels) and Population (in %) in Congo (Republic)?
Keep it short and to the point. 3.45. In the year 1970, what is the difference between the Population (in %) in Heavily indebted poor countries and Population (in %) in Chad?
Provide a succinct answer. -0.91. In the year 1970, what is the difference between the Population (in %) in Heavily indebted poor countries and Population (in %) in Congo (Republic)?
Your answer should be very brief. 0.02. In the year 1970, what is the difference between the Population (in %) of Chad and Population (in %) of Congo (Republic)?
Your response must be concise. 0.93. In the year 1971, what is the difference between the Population (in %) of East Asia (all income levels) and Population (in %) of Heavily indebted poor countries?
Give a very brief answer. 3.6. In the year 1971, what is the difference between the Population (in %) in East Asia (all income levels) and Population (in %) in Chad?
Make the answer very short. 2.68. In the year 1971, what is the difference between the Population (in %) of East Asia (all income levels) and Population (in %) of Congo (Republic)?
Ensure brevity in your answer.  3.62. In the year 1971, what is the difference between the Population (in %) in Heavily indebted poor countries and Population (in %) in Chad?
Offer a terse response. -0.92. In the year 1971, what is the difference between the Population (in %) of Heavily indebted poor countries and Population (in %) of Congo (Republic)?
Your response must be concise. 0.01. In the year 1971, what is the difference between the Population (in %) of Chad and Population (in %) of Congo (Republic)?
Your response must be concise. 0.93. In the year 1972, what is the difference between the Population (in %) of East Asia (all income levels) and Population (in %) of Heavily indebted poor countries?
Provide a succinct answer. 3.76. In the year 1972, what is the difference between the Population (in %) of East Asia (all income levels) and Population (in %) of Chad?
Your answer should be compact. 2.88. In the year 1972, what is the difference between the Population (in %) in East Asia (all income levels) and Population (in %) in Congo (Republic)?
Give a very brief answer. 3.79. In the year 1972, what is the difference between the Population (in %) of Heavily indebted poor countries and Population (in %) of Chad?
Your response must be concise. -0.88. In the year 1972, what is the difference between the Population (in %) of Heavily indebted poor countries and Population (in %) of Congo (Republic)?
Offer a very short reply. 0.04. In the year 1972, what is the difference between the Population (in %) of Chad and Population (in %) of Congo (Republic)?
Your answer should be very brief. 0.91. In the year 1973, what is the difference between the Population (in %) of East Asia (all income levels) and Population (in %) of Heavily indebted poor countries?
Your answer should be compact. 3.9. In the year 1973, what is the difference between the Population (in %) in East Asia (all income levels) and Population (in %) in Chad?
Provide a succinct answer. 3.11. In the year 1973, what is the difference between the Population (in %) in East Asia (all income levels) and Population (in %) in Congo (Republic)?
Offer a very short reply. 3.98. In the year 1973, what is the difference between the Population (in %) in Heavily indebted poor countries and Population (in %) in Chad?
Offer a very short reply. -0.79. In the year 1973, what is the difference between the Population (in %) in Heavily indebted poor countries and Population (in %) in Congo (Republic)?
Provide a succinct answer. 0.08. In the year 1973, what is the difference between the Population (in %) of Chad and Population (in %) of Congo (Republic)?
Provide a succinct answer. 0.87. What is the ratio of the Population (in %) in East Asia (all income levels) in 1966 to that in 1967?
Keep it short and to the point. 1. What is the ratio of the Population (in %) of Heavily indebted poor countries in 1966 to that in 1967?
Give a very brief answer. 1. What is the ratio of the Population (in %) of Chad in 1966 to that in 1967?
Make the answer very short. 1. What is the ratio of the Population (in %) in East Asia (all income levels) in 1966 to that in 1968?
Your response must be concise. 1. What is the ratio of the Population (in %) of Heavily indebted poor countries in 1966 to that in 1968?
Offer a very short reply. 1.01. What is the ratio of the Population (in %) of Chad in 1966 to that in 1968?
Provide a short and direct response. 1. What is the ratio of the Population (in %) of Congo (Republic) in 1966 to that in 1968?
Keep it short and to the point. 1.01. What is the ratio of the Population (in %) of Heavily indebted poor countries in 1966 to that in 1969?
Offer a very short reply. 1.01. What is the ratio of the Population (in %) of Congo (Republic) in 1966 to that in 1969?
Offer a terse response. 1.01. What is the ratio of the Population (in %) of East Asia (all income levels) in 1966 to that in 1970?
Your response must be concise. 0.99. What is the ratio of the Population (in %) in Congo (Republic) in 1966 to that in 1970?
Your answer should be very brief. 1.01. What is the ratio of the Population (in %) in Heavily indebted poor countries in 1966 to that in 1971?
Ensure brevity in your answer.  1.01. What is the ratio of the Population (in %) in Congo (Republic) in 1966 to that in 1971?
Offer a very short reply. 1.02. What is the ratio of the Population (in %) in East Asia (all income levels) in 1966 to that in 1972?
Provide a succinct answer. 1. What is the ratio of the Population (in %) in Heavily indebted poor countries in 1966 to that in 1972?
Your answer should be compact. 1.01. What is the ratio of the Population (in %) in Chad in 1966 to that in 1972?
Keep it short and to the point. 1.01. What is the ratio of the Population (in %) in Congo (Republic) in 1966 to that in 1972?
Offer a terse response. 1.02. What is the ratio of the Population (in %) in East Asia (all income levels) in 1966 to that in 1973?
Your answer should be compact. 0.99. What is the ratio of the Population (in %) in Heavily indebted poor countries in 1966 to that in 1973?
Make the answer very short. 1.02. What is the ratio of the Population (in %) of Chad in 1966 to that in 1973?
Give a very brief answer. 1.01. What is the ratio of the Population (in %) in Congo (Republic) in 1966 to that in 1973?
Make the answer very short. 1.03. What is the ratio of the Population (in %) in Heavily indebted poor countries in 1967 to that in 1968?
Your response must be concise. 1. What is the ratio of the Population (in %) of Chad in 1967 to that in 1968?
Provide a short and direct response. 1. What is the ratio of the Population (in %) of East Asia (all income levels) in 1967 to that in 1969?
Give a very brief answer. 1. What is the ratio of the Population (in %) in Congo (Republic) in 1967 to that in 1969?
Offer a terse response. 1.01. What is the ratio of the Population (in %) of Heavily indebted poor countries in 1967 to that in 1970?
Give a very brief answer. 1. What is the ratio of the Population (in %) in Chad in 1967 to that in 1970?
Make the answer very short. 1. What is the ratio of the Population (in %) of Congo (Republic) in 1967 to that in 1970?
Provide a short and direct response. 1.01. What is the ratio of the Population (in %) of East Asia (all income levels) in 1967 to that in 1971?
Offer a very short reply. 1. What is the ratio of the Population (in %) in Heavily indebted poor countries in 1967 to that in 1971?
Your answer should be very brief. 1.01. What is the ratio of the Population (in %) in Congo (Republic) in 1967 to that in 1971?
Keep it short and to the point. 1.01. What is the ratio of the Population (in %) of Heavily indebted poor countries in 1967 to that in 1972?
Offer a very short reply. 1.01. What is the ratio of the Population (in %) of Chad in 1967 to that in 1972?
Make the answer very short. 1.01. What is the ratio of the Population (in %) of Congo (Republic) in 1967 to that in 1972?
Ensure brevity in your answer.  1.02. What is the ratio of the Population (in %) in Heavily indebted poor countries in 1967 to that in 1973?
Your answer should be very brief. 1.01. What is the ratio of the Population (in %) in Chad in 1967 to that in 1973?
Keep it short and to the point. 1.01. What is the ratio of the Population (in %) of Congo (Republic) in 1967 to that in 1973?
Ensure brevity in your answer.  1.02. What is the ratio of the Population (in %) of Congo (Republic) in 1968 to that in 1969?
Keep it short and to the point. 1. What is the ratio of the Population (in %) of East Asia (all income levels) in 1968 to that in 1970?
Offer a terse response. 1. What is the ratio of the Population (in %) of Chad in 1968 to that in 1970?
Offer a very short reply. 1. What is the ratio of the Population (in %) of East Asia (all income levels) in 1968 to that in 1971?
Offer a terse response. 1. What is the ratio of the Population (in %) in Congo (Republic) in 1968 to that in 1971?
Offer a very short reply. 1.01. What is the ratio of the Population (in %) of East Asia (all income levels) in 1968 to that in 1972?
Provide a succinct answer. 1. What is the ratio of the Population (in %) of Heavily indebted poor countries in 1968 to that in 1972?
Give a very brief answer. 1.01. What is the ratio of the Population (in %) in East Asia (all income levels) in 1968 to that in 1973?
Provide a succinct answer. 1. What is the ratio of the Population (in %) in Heavily indebted poor countries in 1968 to that in 1973?
Ensure brevity in your answer.  1.01. What is the ratio of the Population (in %) of Chad in 1968 to that in 1973?
Ensure brevity in your answer.  1.01. What is the ratio of the Population (in %) in Congo (Republic) in 1968 to that in 1973?
Provide a short and direct response. 1.02. What is the ratio of the Population (in %) of Heavily indebted poor countries in 1969 to that in 1970?
Your answer should be compact. 1. What is the ratio of the Population (in %) in Chad in 1969 to that in 1970?
Keep it short and to the point. 1. What is the ratio of the Population (in %) of Congo (Republic) in 1969 to that in 1970?
Offer a very short reply. 1. What is the ratio of the Population (in %) of Heavily indebted poor countries in 1969 to that in 1971?
Provide a succinct answer. 1. What is the ratio of the Population (in %) of Chad in 1969 to that in 1971?
Provide a succinct answer. 1. What is the ratio of the Population (in %) in Congo (Republic) in 1969 to that in 1971?
Ensure brevity in your answer.  1.01. What is the ratio of the Population (in %) of East Asia (all income levels) in 1969 to that in 1972?
Your answer should be compact. 1. What is the ratio of the Population (in %) in Chad in 1969 to that in 1972?
Keep it short and to the point. 1.01. What is the ratio of the Population (in %) of Congo (Republic) in 1969 to that in 1972?
Keep it short and to the point. 1.01. What is the ratio of the Population (in %) in East Asia (all income levels) in 1969 to that in 1973?
Keep it short and to the point. 1. What is the ratio of the Population (in %) in Chad in 1969 to that in 1973?
Ensure brevity in your answer.  1.01. What is the ratio of the Population (in %) in Congo (Republic) in 1969 to that in 1973?
Ensure brevity in your answer.  1.01. What is the ratio of the Population (in %) in Heavily indebted poor countries in 1970 to that in 1971?
Offer a very short reply. 1. What is the ratio of the Population (in %) of Congo (Republic) in 1970 to that in 1971?
Keep it short and to the point. 1. What is the ratio of the Population (in %) of East Asia (all income levels) in 1970 to that in 1972?
Your answer should be compact. 1. What is the ratio of the Population (in %) in Heavily indebted poor countries in 1970 to that in 1972?
Your response must be concise. 1.01. What is the ratio of the Population (in %) of Chad in 1970 to that in 1972?
Keep it short and to the point. 1.01. What is the ratio of the Population (in %) of Congo (Republic) in 1970 to that in 1972?
Your response must be concise. 1.01. What is the ratio of the Population (in %) of Heavily indebted poor countries in 1970 to that in 1973?
Offer a very short reply. 1.01. What is the ratio of the Population (in %) in Chad in 1970 to that in 1973?
Make the answer very short. 1.01. What is the ratio of the Population (in %) of Congo (Republic) in 1970 to that in 1973?
Make the answer very short. 1.01. What is the ratio of the Population (in %) of East Asia (all income levels) in 1971 to that in 1972?
Provide a short and direct response. 1. What is the ratio of the Population (in %) in Chad in 1971 to that in 1972?
Provide a short and direct response. 1. What is the ratio of the Population (in %) in Congo (Republic) in 1971 to that in 1972?
Your answer should be compact. 1. What is the ratio of the Population (in %) of Chad in 1971 to that in 1973?
Keep it short and to the point. 1.01. What is the ratio of the Population (in %) in Congo (Republic) in 1971 to that in 1973?
Offer a terse response. 1.01. What is the ratio of the Population (in %) in Congo (Republic) in 1972 to that in 1973?
Provide a short and direct response. 1. What is the difference between the highest and the second highest Population (in %) in East Asia (all income levels)?
Give a very brief answer. 0.03. What is the difference between the highest and the second highest Population (in %) in Heavily indebted poor countries?
Provide a short and direct response. 0.17. What is the difference between the highest and the second highest Population (in %) in Chad?
Provide a succinct answer. 0.05. What is the difference between the highest and the second highest Population (in %) of Congo (Republic)?
Give a very brief answer. 0.25. What is the difference between the highest and the lowest Population (in %) in East Asia (all income levels)?
Offer a very short reply. 0.33. What is the difference between the highest and the lowest Population (in %) in Heavily indebted poor countries?
Your response must be concise. 0.87. What is the difference between the highest and the lowest Population (in %) of Chad?
Keep it short and to the point. 0.62. What is the difference between the highest and the lowest Population (in %) in Congo (Republic)?
Ensure brevity in your answer.  1.32. 